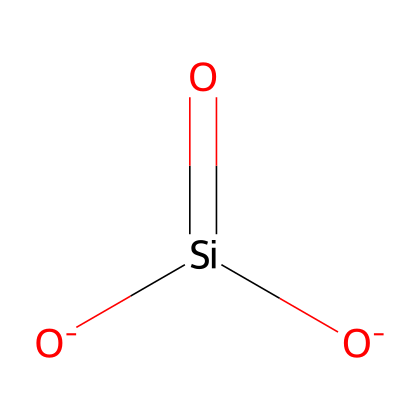What is the main element present in this chemical? The chemical structure includes silicon, indicated by the presence of the Si symbol. This shows that silicon is the primary element in this molecular structure.
Answer: silicon How many oxygen atoms are present in the chemical? From the SMILES representation, there are two oxygen atoms indicated by the two [O] in the structure. This shows that the compound contains two oxygen atoms.
Answer: two What functional groups are present in this chemical? The structure shows the presence of silicate functional groups, characterized by silicon bonded to oxygen atoms. This composition identifies it as a silicate.
Answer: silicate What type of behavior is indicated by this chemical under stress? Non-Newtonian fluids typically change their viscosity under stress; thus, this silica nanoparticle structure suggests shear-thinning behavior, meaning it becomes less viscous when stirred or shaken.
Answer: shear-thinning How does this chemical contribute to the preservation of historical artifacts? Silica nanoparticles enhance the mechanical stability and UV protection of the paint preservatives, which prevents degradation. This indicates the significance of their structural properties in preservation strategies.
Answer: mechanical stability and UV protection What structural characteristics enable this chemical to alter viscosity? The specific network of silicon and oxygen in silica nanoparticles allows for the absorption and release of energy, changing its viscosity in response to applied stress, characteristic of non-Newtonian fluids.
Answer: network of silicon and oxygen Which property allows this chemical to interact with paint matrices? The silicate structure presents reactive sites that can bond with organic materials in paint, facilitating better integration within paint systems. This interaction is key for enhancing the overall quality of paint preservatives.
Answer: reactive sites 